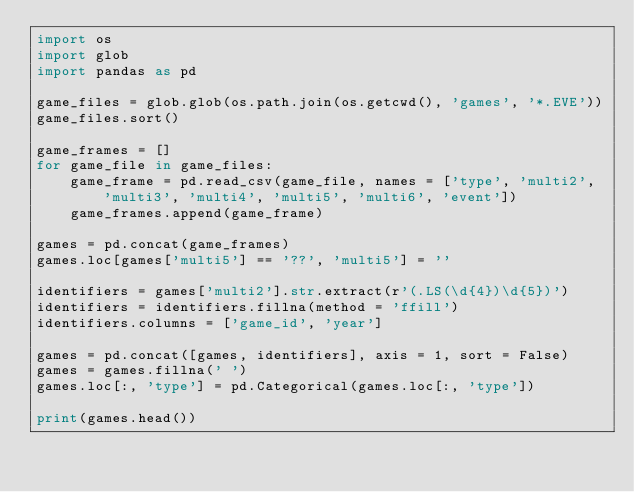Convert code to text. <code><loc_0><loc_0><loc_500><loc_500><_Python_>import os
import glob
import pandas as pd

game_files = glob.glob(os.path.join(os.getcwd(), 'games', '*.EVE'))
game_files.sort()

game_frames = []
for game_file in game_files:
    game_frame = pd.read_csv(game_file, names = ['type', 'multi2', 'multi3', 'multi4', 'multi5', 'multi6', 'event'])
    game_frames.append(game_frame)

games = pd.concat(game_frames)
games.loc[games['multi5'] == '??', 'multi5'] = ''

identifiers = games['multi2'].str.extract(r'(.LS(\d{4})\d{5})')
identifiers = identifiers.fillna(method = 'ffill')
identifiers.columns = ['game_id', 'year']

games = pd.concat([games, identifiers], axis = 1, sort = False)
games = games.fillna(' ')
games.loc[:, 'type'] = pd.Categorical(games.loc[:, 'type'])

print(games.head())
</code> 